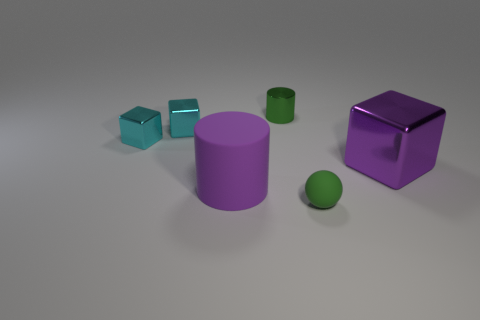What could be the purpose of these objects given their shapes and sizes? The objects seem to represent basic geometric shapes commonly used in educational contexts to teach about volume, geometry, and spatial awareness. Due to their varied shapes and sizes—ranging from small to large cubes, a cylindrical shape, and a sphere—they could serve educational purposes such as demonstrating the properties of three-dimensional figures. 